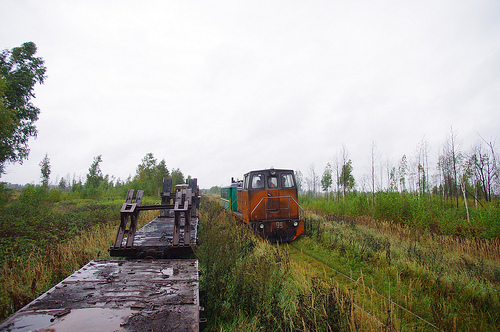What does the setting tell us about the likely location of the train? The setting, with its lush greenery and overcast sky, suggests a rural area likely subject to frequent rain, which points to a temperate climate zone. The absence of urban structures or heavy industry in the immediate vicinity indicates the train might be on a line used for regional transport or industrial purposes in a less populated region. 